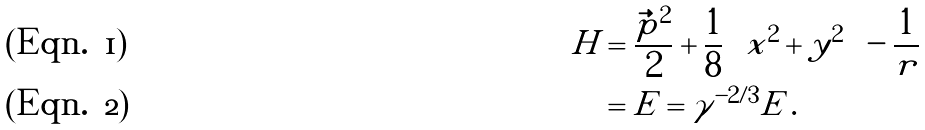Convert formula to latex. <formula><loc_0><loc_0><loc_500><loc_500>\tilde { H } & = \frac { \tilde { \vec { p } } ^ { 2 } } { 2 } + \frac { 1 } { 8 } \left ( \tilde { x } ^ { 2 } + \tilde { y } ^ { 2 } \right ) - \frac { 1 } { \tilde { r } } \\ & = \tilde { E } = \gamma ^ { - 2 / 3 } E \, .</formula> 